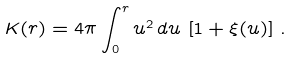<formula> <loc_0><loc_0><loc_500><loc_500>K ( r ) = 4 \pi \int _ { 0 } ^ { r } u ^ { 2 } \, d u \, \left [ 1 + \xi ( u ) \right ] \, .</formula> 